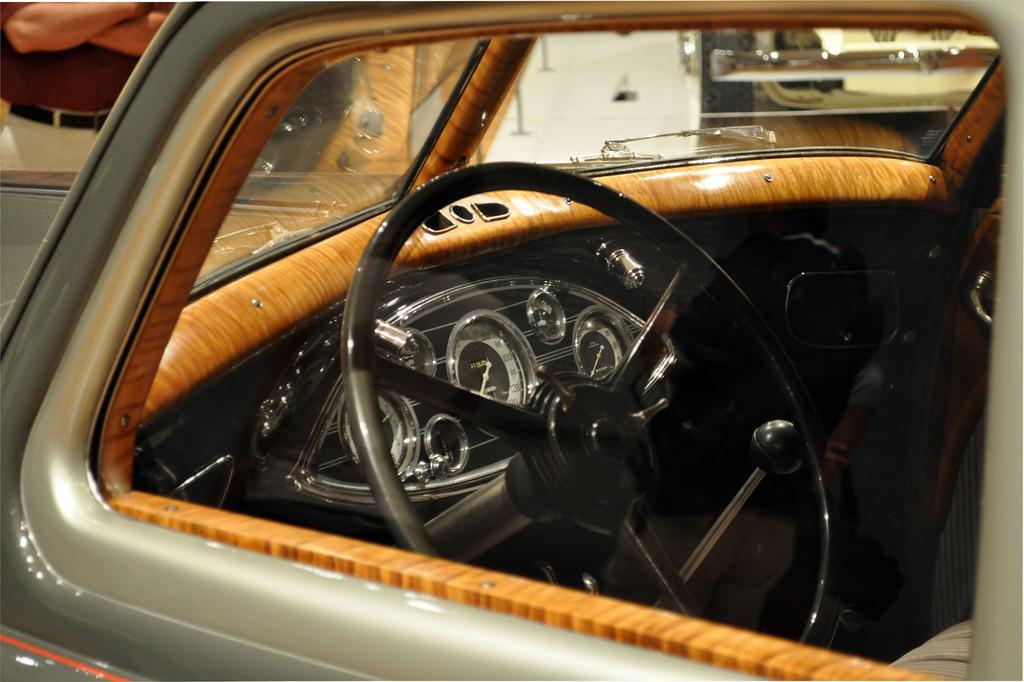Describe this image in one or two sentences. In this picture I can observe a car. In the middle of the picture there is a steering. On the top left side I can observe a person. 